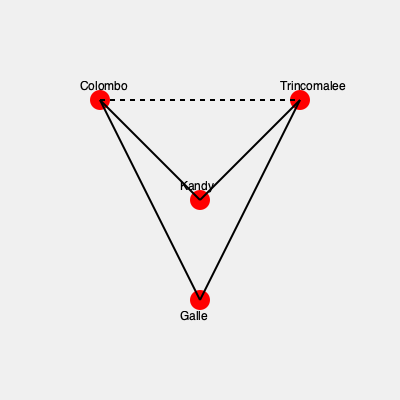In the simplified road map of Sri Lanka shown above, which route represents the shortest path between Colombo and Trincomalee? To determine the shortest path between Colombo and Trincomalee, we need to compare the available routes:

1. Direct route (dashed line):
   - This is a straight line between Colombo and Trincomalee.
   - In real-world scenarios, direct routes are typically the shortest.

2. Route via Kandy:
   - Colombo to Kandy, then Kandy to Trincomalee.
   - This route forms two sides of a triangle.

3. Route via Galle:
   - Colombo to Galle, then Galle to Trincomalee.
   - This route takes a significant detour to the south.

Comparing these options:
- The direct route (dashed line) is visually the shortest distance between the two points.
- The route via Kandy forms two sides of a triangle, which is always longer than the direct path (hypotenuse).
- The route via Galle is clearly longer as it goes far south before turning north.

In geometric terms, a straight line is always the shortest distance between two points. Therefore, the direct route (represented by the dashed line) is the shortest path between Colombo and Trincomalee.
Answer: The direct route (dashed line) 